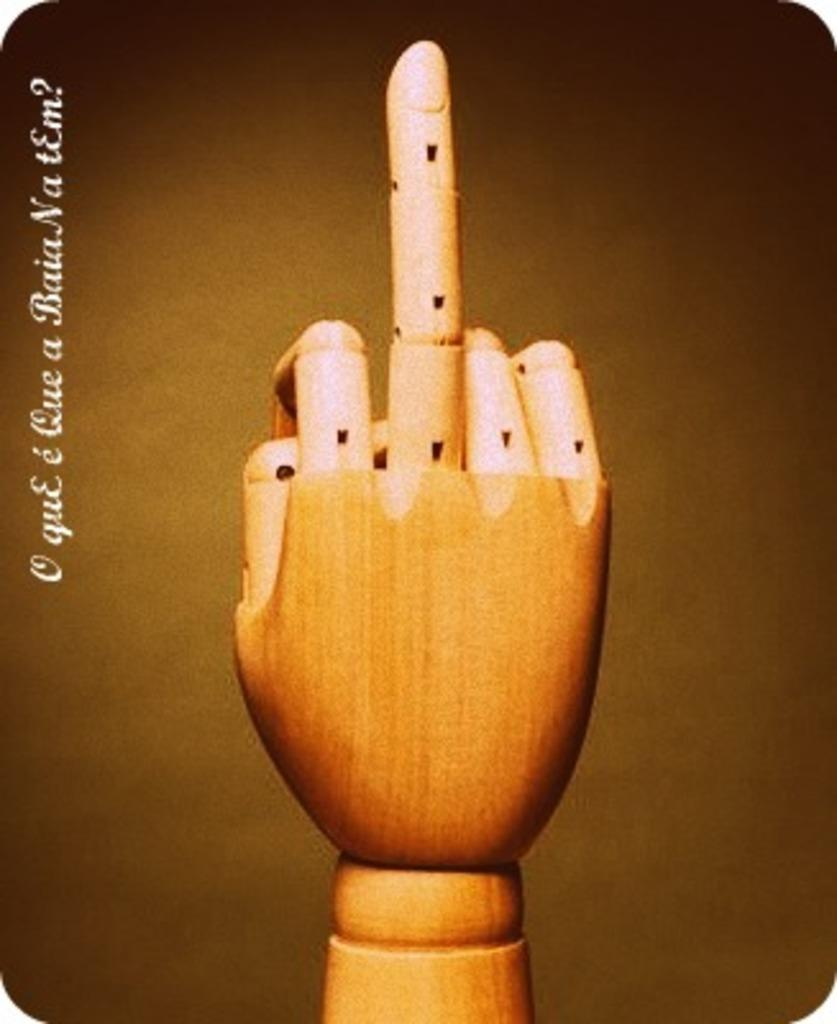What is the main subject of the image? The main subject of the image is a wooden hand. What is the wooden hand doing in the image? The wooden hand is pointing the middle finger. Is there any additional detail visible on the image? Yes, there is a watermark on the left side of the image. Can you see any cactus plants in the wilderness depicted in the image? There is no wilderness or cactus plants present in the image; it features a wooden hand pointing the middle finger and a watermark on the left side. 